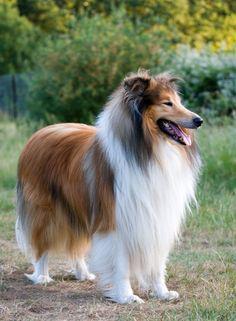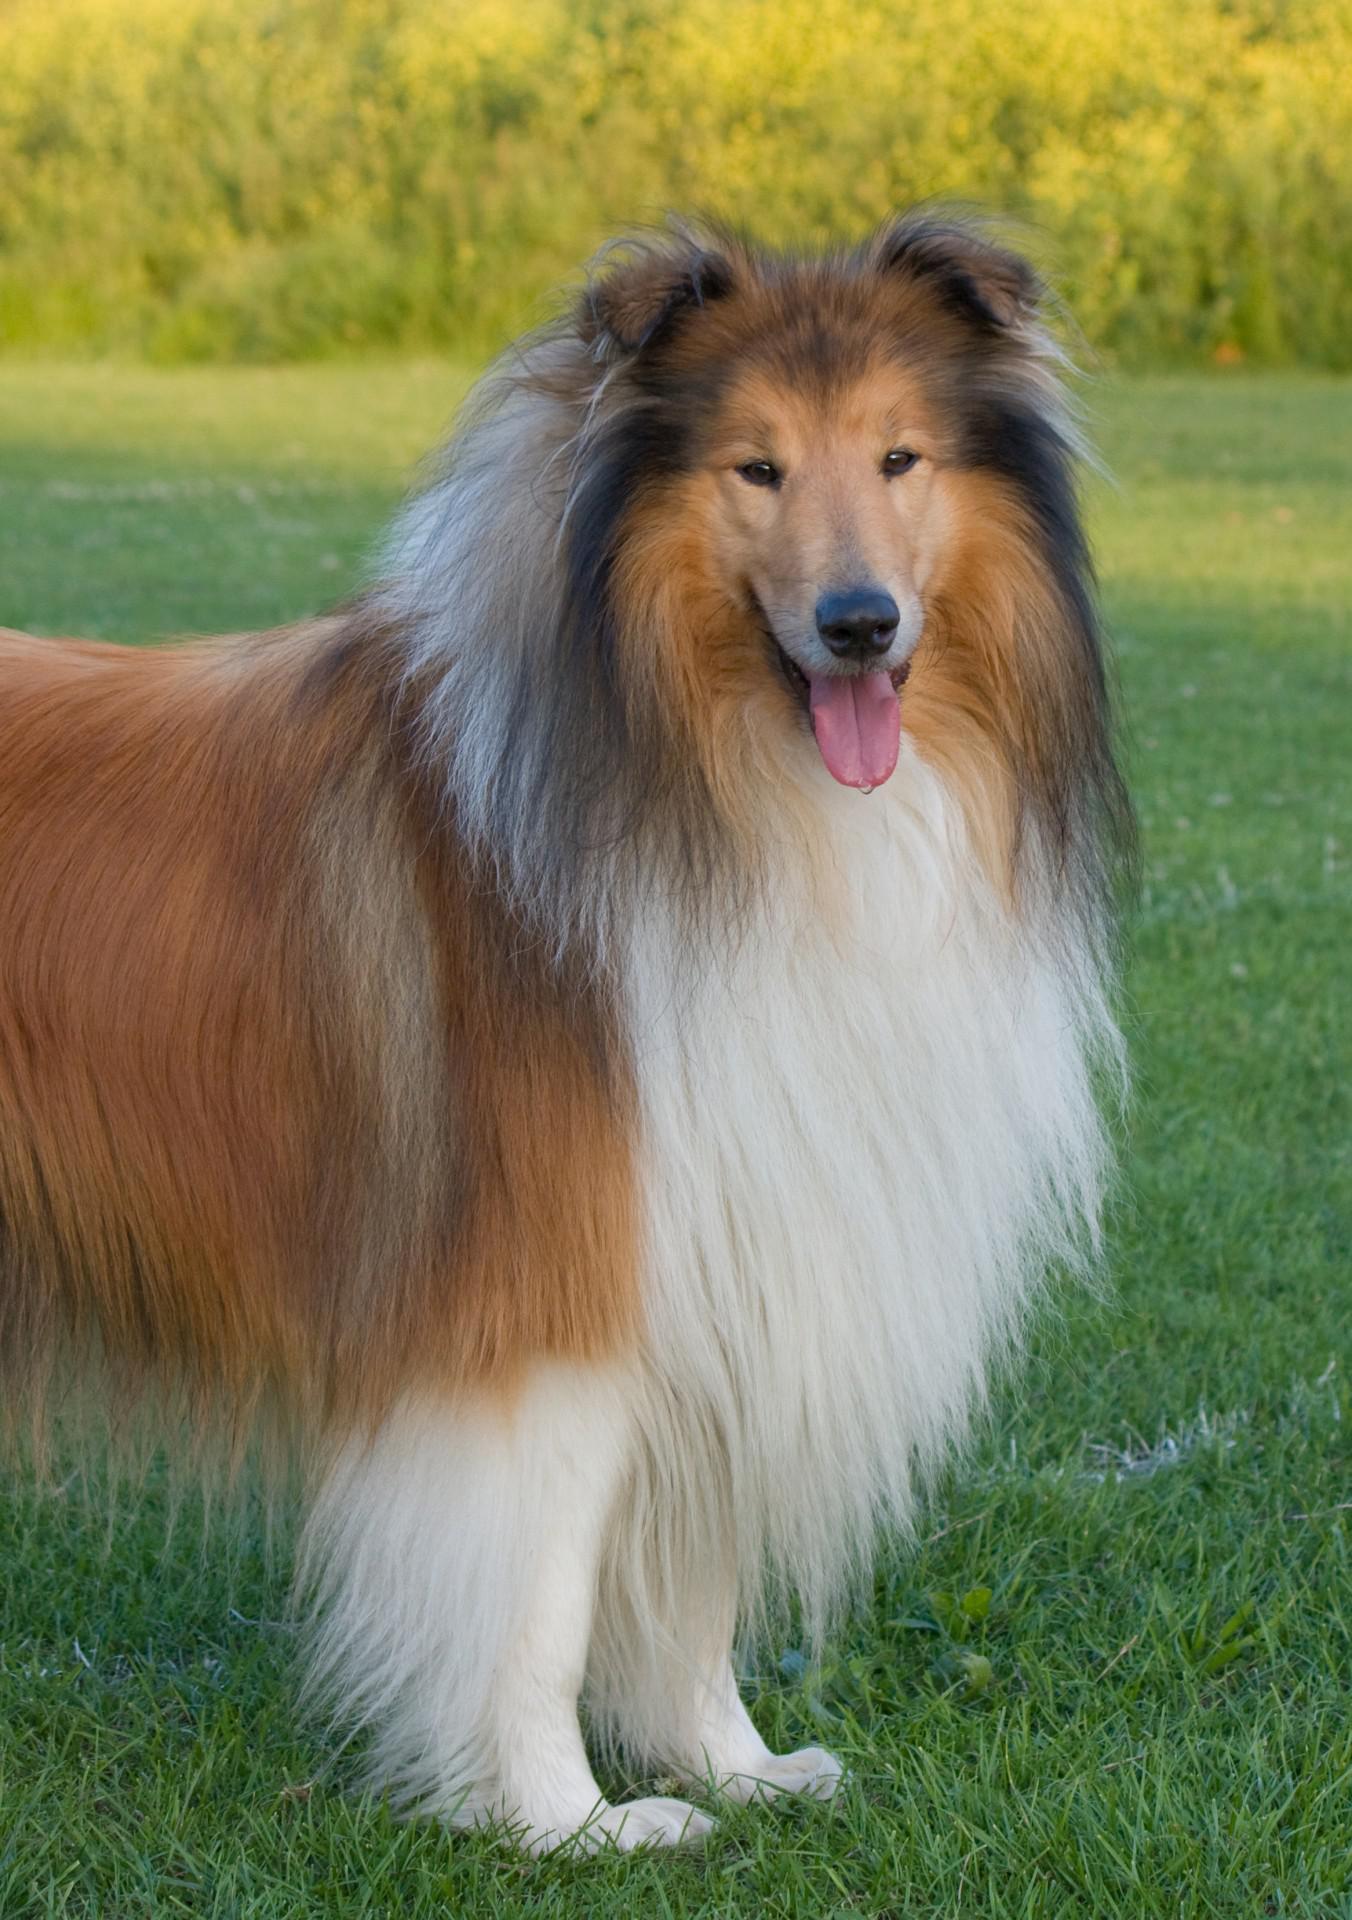The first image is the image on the left, the second image is the image on the right. Examine the images to the left and right. Is the description "both collies are standing and facing left" accurate? Answer yes or no. No. 